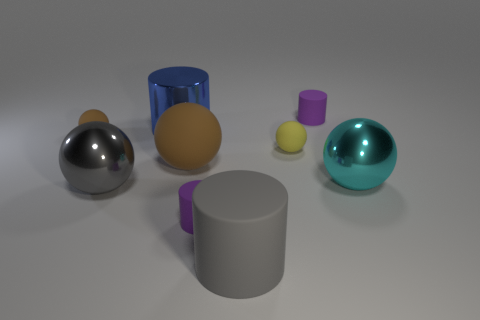How many tiny rubber things are the same shape as the cyan shiny thing?
Keep it short and to the point. 2. Is there a thing of the same color as the large rubber sphere?
Your answer should be very brief. Yes. Do the purple thing behind the blue object and the tiny sphere left of the yellow rubber object have the same material?
Provide a succinct answer. Yes. What is the color of the metallic cylinder?
Make the answer very short. Blue. What size is the shiny object that is behind the tiny rubber ball that is in front of the brown matte object that is behind the large brown rubber ball?
Give a very brief answer. Large. What number of other objects are the same size as the yellow rubber thing?
Offer a very short reply. 3. How many large green objects have the same material as the big cyan object?
Keep it short and to the point. 0. There is a small purple matte thing behind the large gray sphere; what shape is it?
Your answer should be compact. Cylinder. Does the blue cylinder have the same material as the large gray object that is behind the gray matte thing?
Your response must be concise. Yes. Are any tiny metal objects visible?
Give a very brief answer. No. 